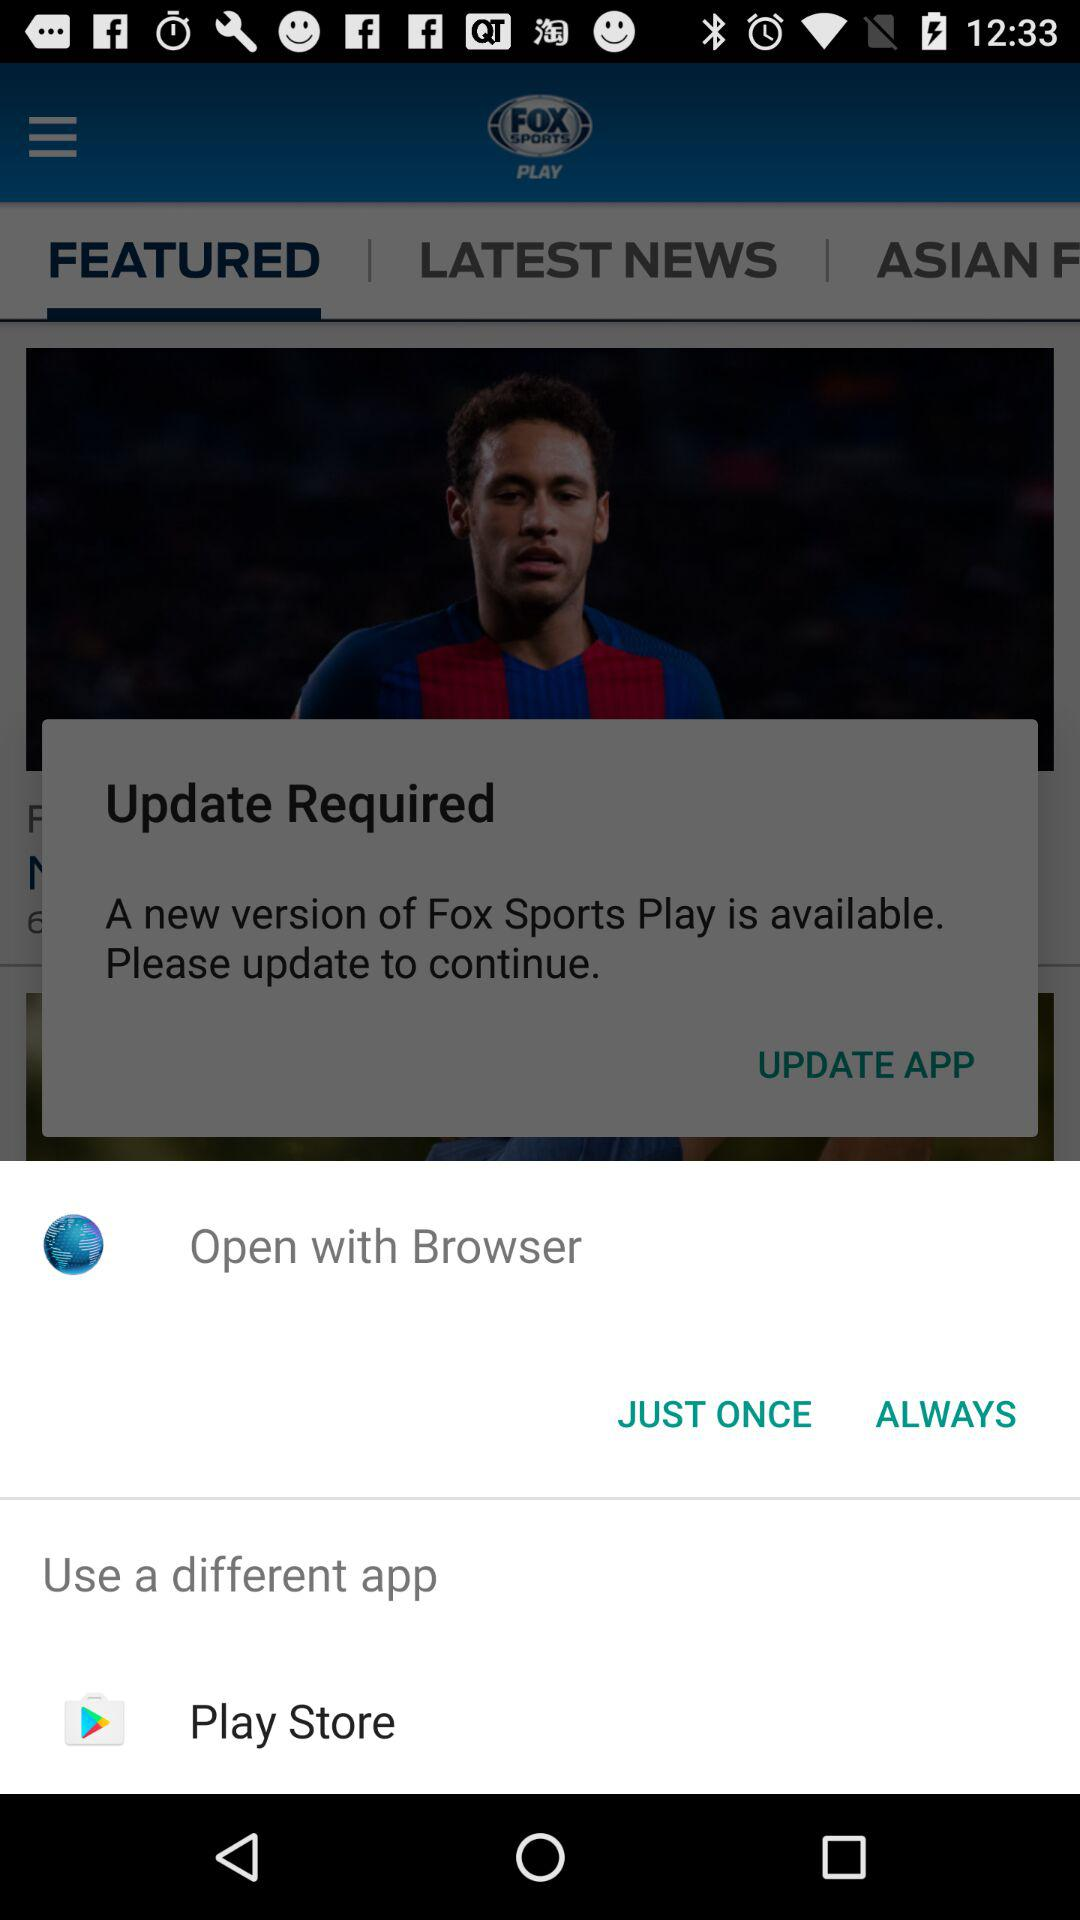Which options are given to open it with? The options given to open it are "Browser" and "Play Store". 